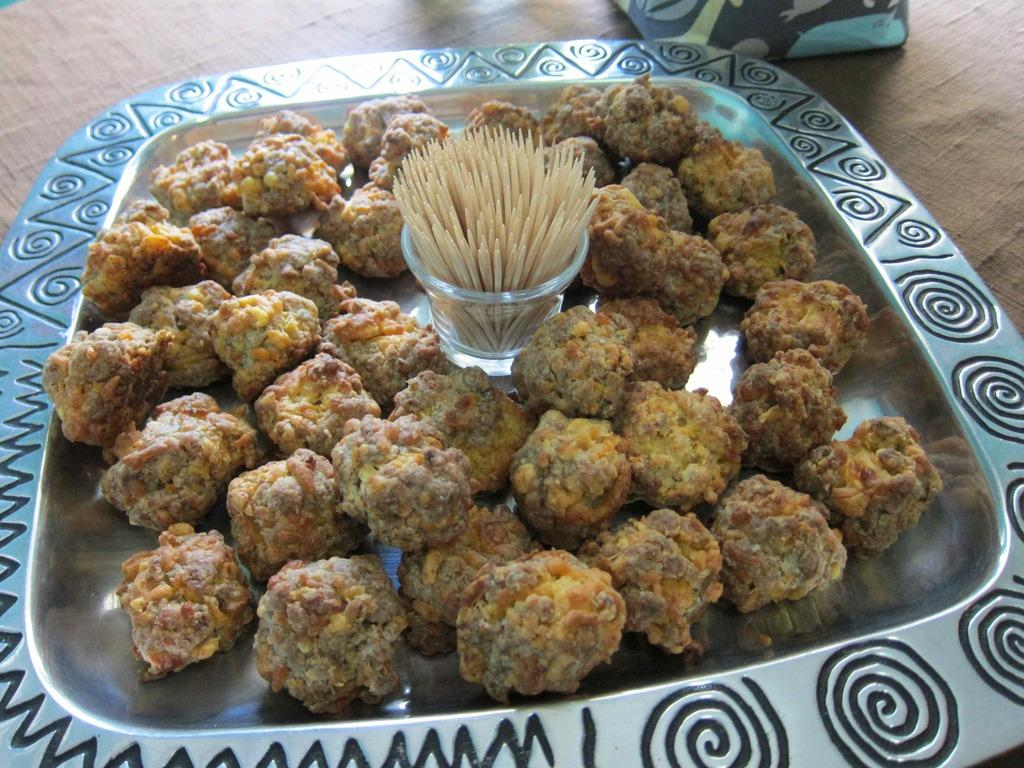What is present in the image related to food? There is food in the image. How is the food arranged or presented? The food is in a plate. Are there any utensils or accessories visible with the food? Yes, there are toothpicks in the middle of the plate. What type of car is parked next to the plate of food in the image? There is no car present in the image; it only features food in a plate with toothpicks. 